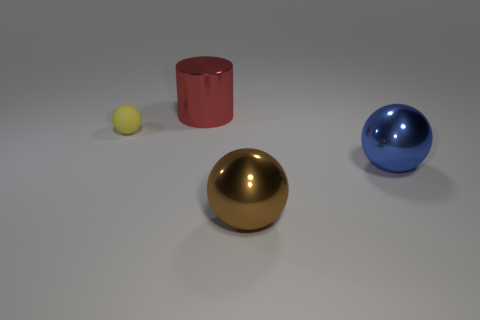Subtract all blue spheres. How many spheres are left? 2 Add 3 brown blocks. How many objects exist? 7 Subtract all blue balls. How many balls are left? 2 Subtract all spheres. How many objects are left? 1 Subtract 2 spheres. How many spheres are left? 1 Add 4 large red shiny cylinders. How many large red shiny cylinders are left? 5 Add 3 brown metallic objects. How many brown metallic objects exist? 4 Subtract 0 blue cylinders. How many objects are left? 4 Subtract all gray spheres. Subtract all cyan cylinders. How many spheres are left? 3 Subtract all gray cylinders. How many blue balls are left? 1 